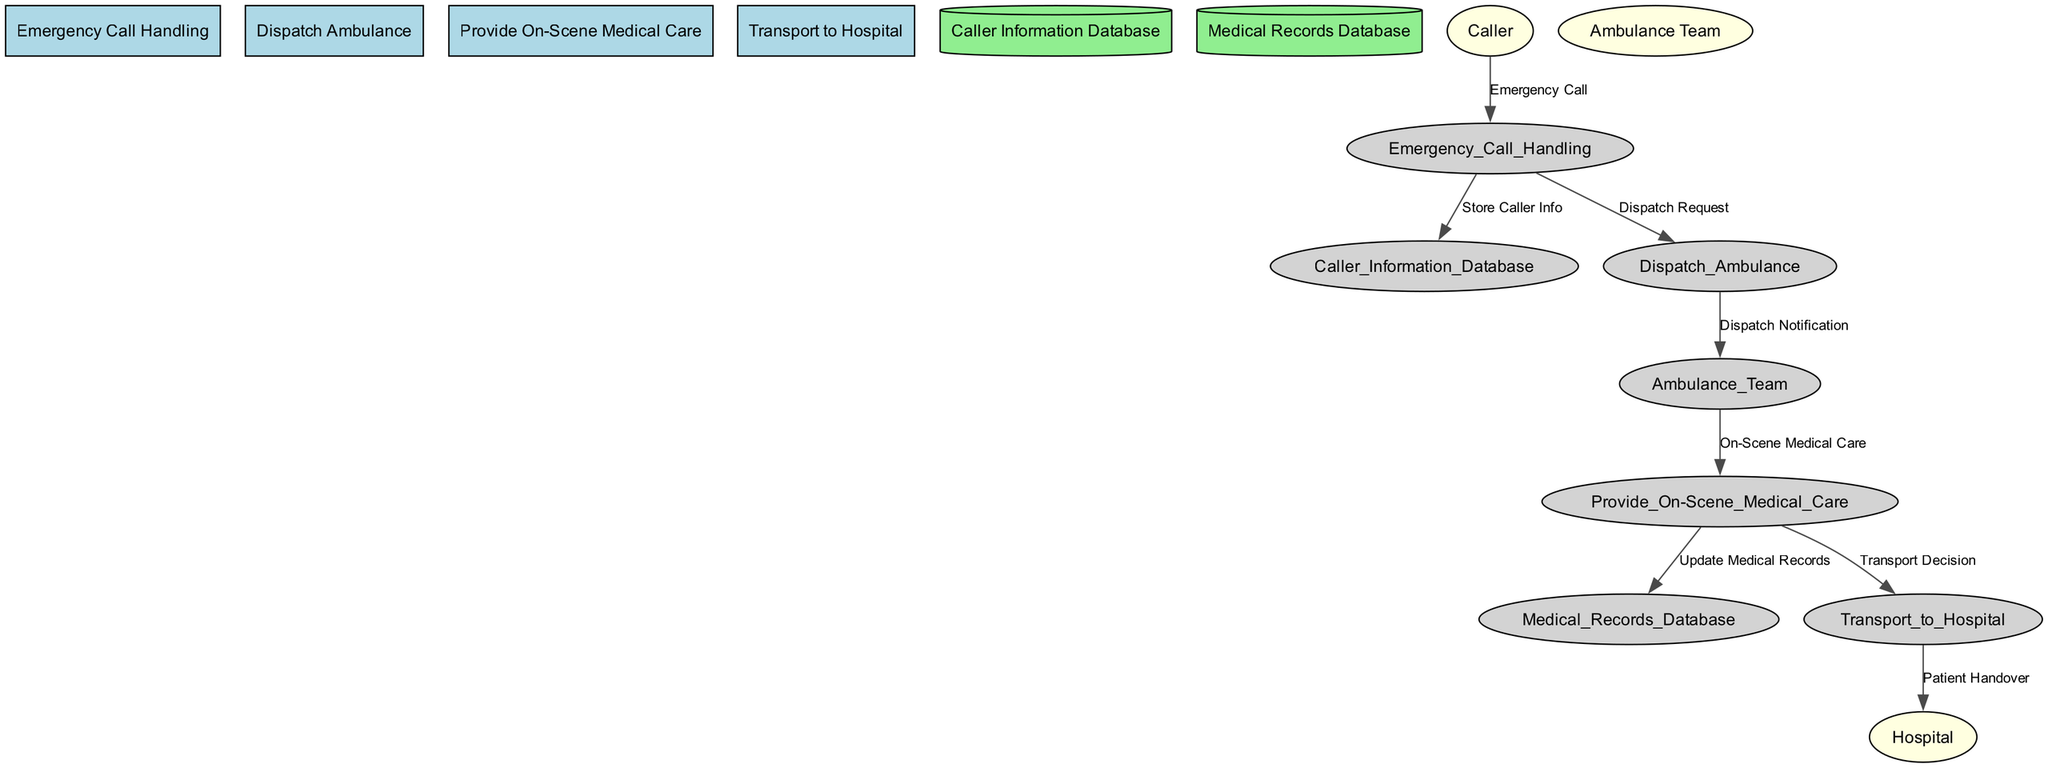What is the first process in the workflow? The first process listed in the diagram is "Emergency Call Handling," which is the initial step in the emergency medical services workflow.
Answer: Emergency Call Handling How many data stores are present in the diagram? There are two data stores indicated in the diagram: the "Caller Information Database" and the "Medical Records Database."
Answer: 2 Who is the external entity that initiates the emergency call? The external entity that initiates the emergency call is the "Caller," who contacts the Emergency Call Handling process to report an emergency.
Answer: Caller What does the "Dispatch Ambulance" process receive from "Emergency Call Handling"? The "Dispatch Ambulance" process receives a "Dispatch Request," which includes the necessary information to send an ambulance to the emergency location.
Answer: Dispatch Request Which process updates the medical records database? The process responsible for updating the medical records database is "Provide On-Scene Medical Care," as it captures all relevant medical information during the emergency care.
Answer: Provide On-Scene Medical Care Who receives the "Patient Handover" at the end of the workflow? The "Patient Handover" is received by the external entity referred to as the "Hospital," where the patient is transferred for further medical care.
Answer: Hospital What is the flow of information from "Ambulance Team" to "Transport to Hospital"? The Ambulance Team provides an "On-Scene Medical Care" to the patient, which informs the "Transport to Hospital" process regarding whether the patient needs to be transported.
Answer: On-Scene Medical Care What type of information is stored in the "Caller Information Database"? The "Caller Information Database" stores information related to the caller who made the emergency call, including contact details and the nature of the emergency.
Answer: Caller Info Which processes are directly connected in the diagram without any data stores? The processes "Emergency Call Handling" and "Dispatch Ambulance" are directly connected, as well as "Provide On-Scene Medical Care" and "Transport to Hospital."
Answer: Emergency Call Handling and Dispatch Ambulance; Provide On-Scene Medical Care and Transport to Hospital 